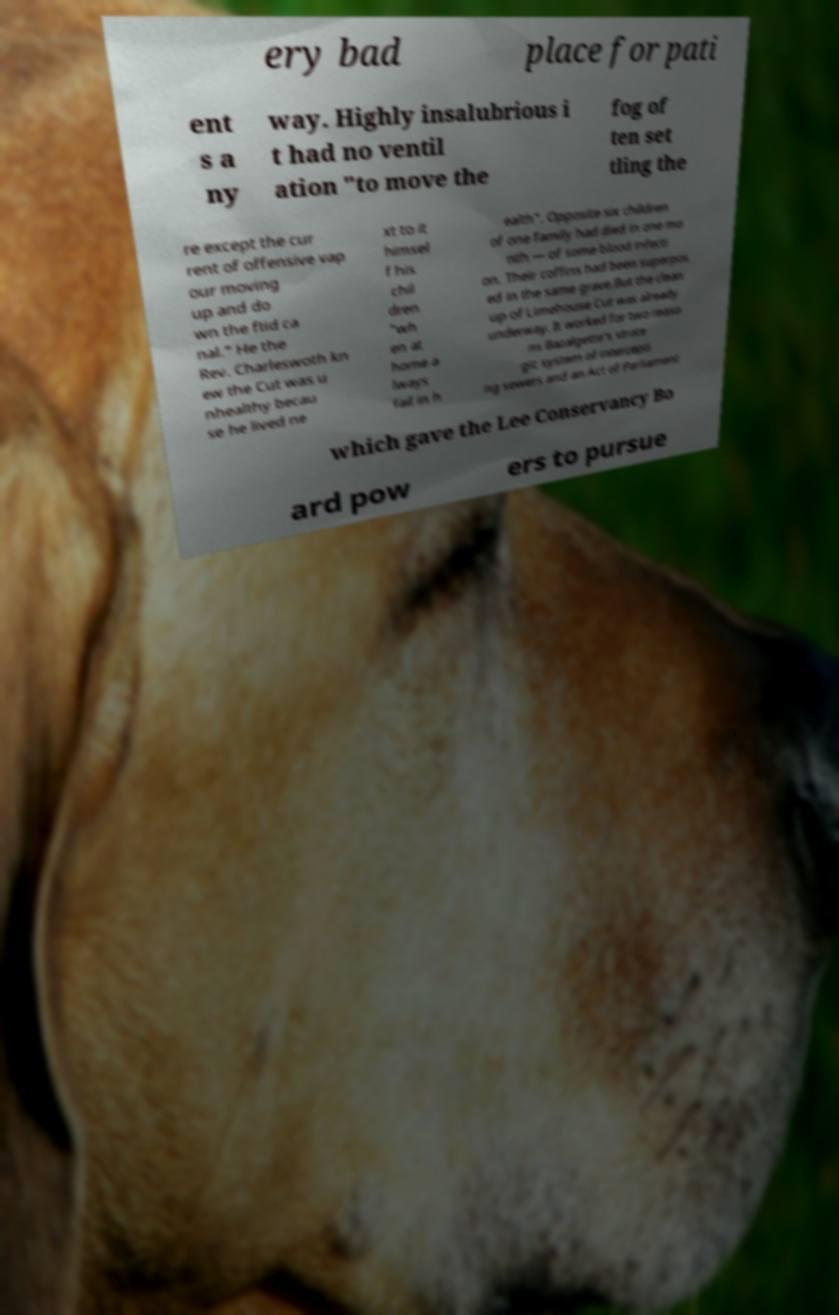Please identify and transcribe the text found in this image. ery bad place for pati ent s a ny way. Highly insalubrious i t had no ventil ation "to move the fog of ten set tling the re except the cur rent of offensive vap our moving up and do wn the ftid ca nal." He the Rev. Charleswoth kn ew the Cut was u nhealthy becau se he lived ne xt to it himsel f his chil dren "wh en at home a lways fail in h ealth". Opposite six children of one family had died in one mo nth — of some blood infecti on. Their coffins had been superpos ed in the same grave.But the clean up of Limehouse Cut was already underway. It worked for two reaso ns Bazalgette's strate gic system of intercepti ng sewers and an Act of Parliament which gave the Lee Conservancy Bo ard pow ers to pursue 